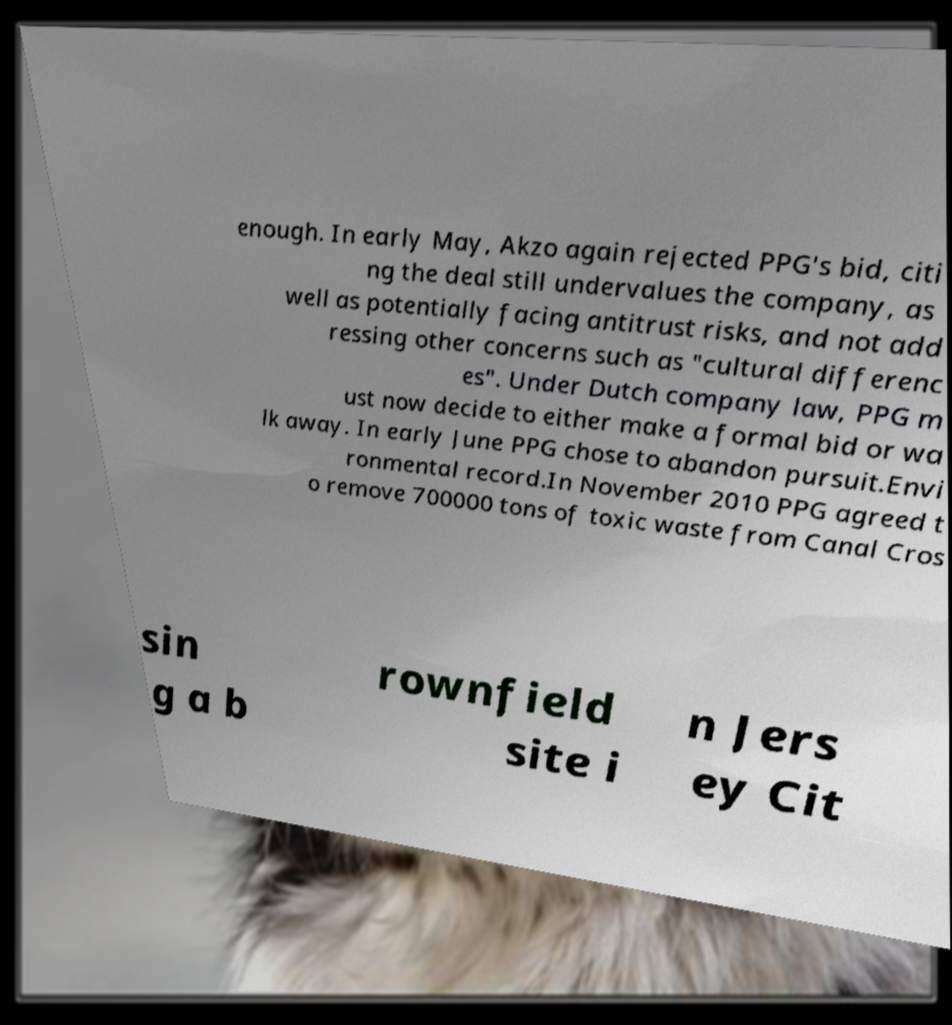Can you read and provide the text displayed in the image?This photo seems to have some interesting text. Can you extract and type it out for me? enough. In early May, Akzo again rejected PPG's bid, citi ng the deal still undervalues the company, as well as potentially facing antitrust risks, and not add ressing other concerns such as "cultural differenc es". Under Dutch company law, PPG m ust now decide to either make a formal bid or wa lk away. In early June PPG chose to abandon pursuit.Envi ronmental record.In November 2010 PPG agreed t o remove 700000 tons of toxic waste from Canal Cros sin g a b rownfield site i n Jers ey Cit 